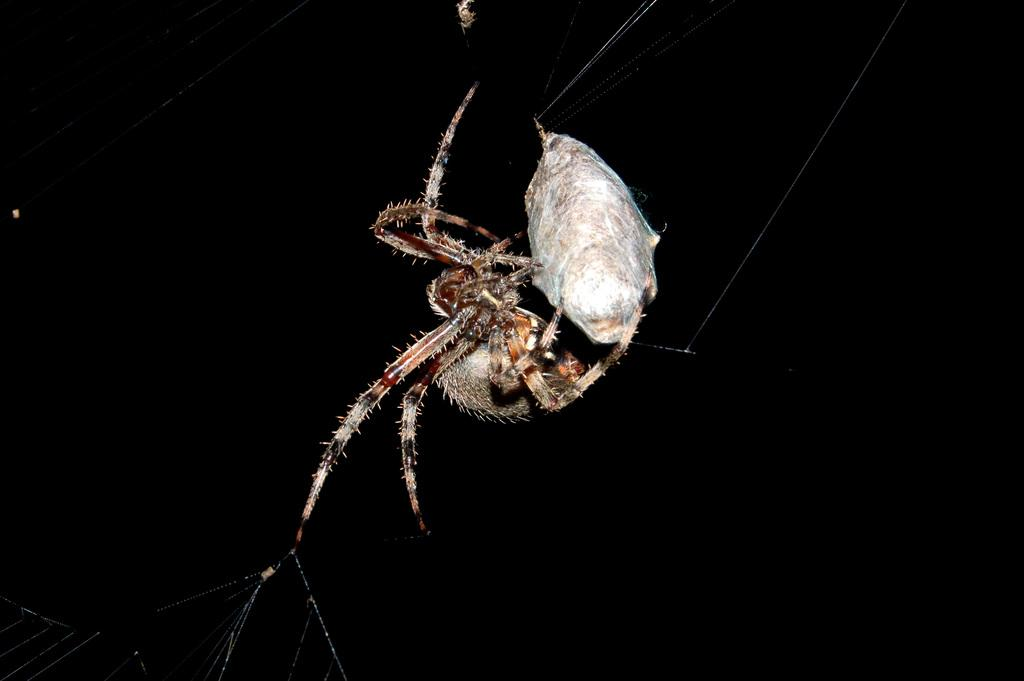What is the main subject of the image? The main subject of the image is a spider. What is the spider associated with in the image? There is a spider web in the image. What can be observed about the overall appearance of the image? The background of the image is dark. What type of veil is draped over the spider in the image? There is no veil present in the image; it features a spider and a spider web. What historical event is depicted in the image? The image does not depict any historical event; it focuses on a spider and a spider web. 